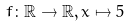Convert formula to latex. <formula><loc_0><loc_0><loc_500><loc_500>f \colon \mathbb { R } \rightarrow \mathbb { R } , x \mapsto 5</formula> 